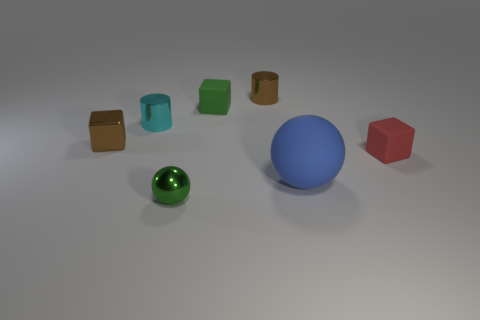Add 2 green matte things. How many objects exist? 9 Subtract all cylinders. How many objects are left? 5 Subtract all brown cylinders. Subtract all green metallic things. How many objects are left? 5 Add 6 metal blocks. How many metal blocks are left? 7 Add 3 large rubber objects. How many large rubber objects exist? 4 Subtract 1 green spheres. How many objects are left? 6 